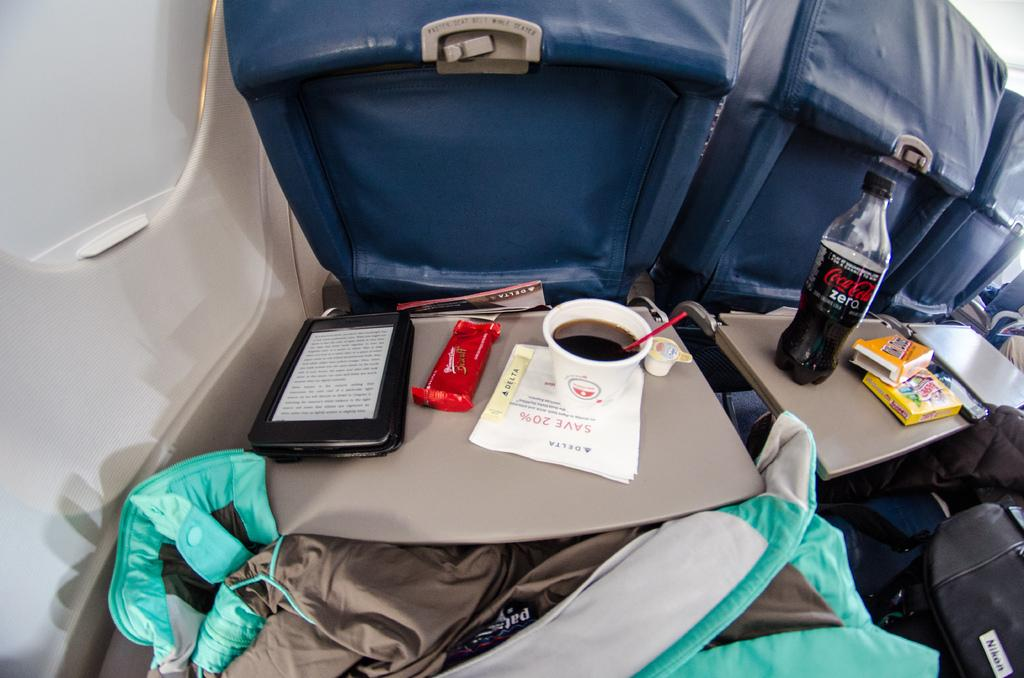What is in the image that can be used for holding liquids? There is a cup and a bottle in the image that can be used for holding liquids. What type of food or ingredient is present in the image? There is chocolate in the image. What is the flat surface on which the cup, bottle, and chocolate are placed? There is a table in the image. What object can be seen in the image that is typically used for writing or reading? There is a paper in the image. Can you describe the background of the image? There is a chair in the background of the image. What type of shade is provided by the chocolate in the image? There is no shade provided by the chocolate in the image, as it is a food item and not a source of shade. 